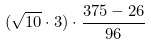<formula> <loc_0><loc_0><loc_500><loc_500>( \sqrt { 1 0 } \cdot 3 ) \cdot \frac { 3 7 5 - 2 6 } { 9 6 }</formula> 